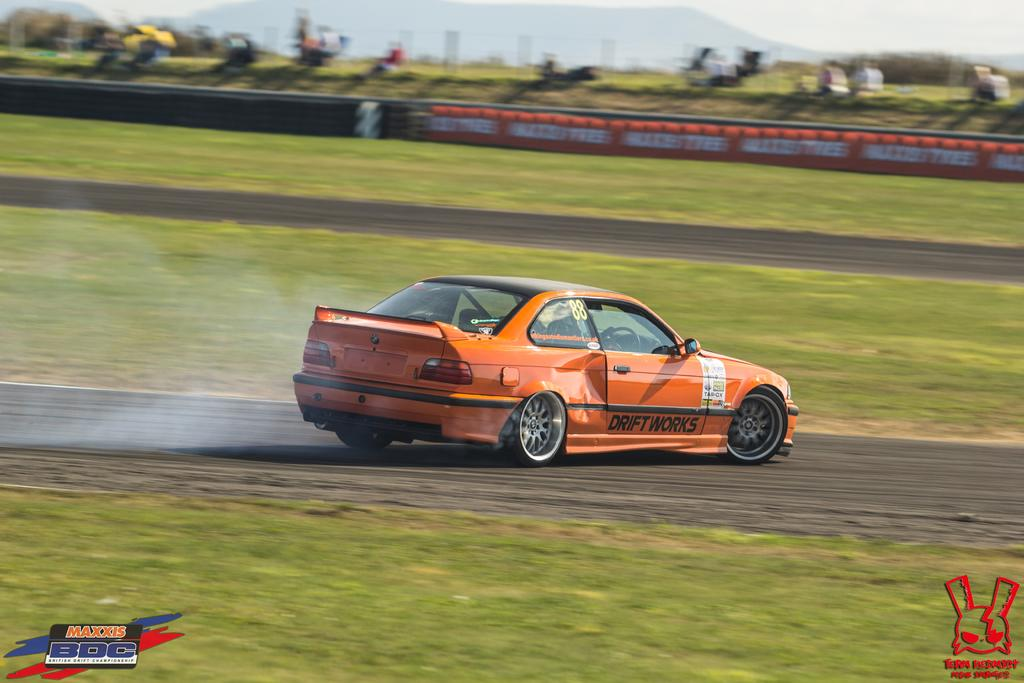What color is the car in the image? The car in the image is orange. Where is the car located in the image? The car is on a racing track. Can you describe the background of the image? The background of the image is blurred. Are there any additional features on the image? Yes, there are two watermarks on the bottom side of the image. Can you see any monkeys or owls in the image? No, there are no monkeys or owls present in the image. What type of ocean can be seen in the background of the image? There is no ocean visible in the image; the background is blurred. 